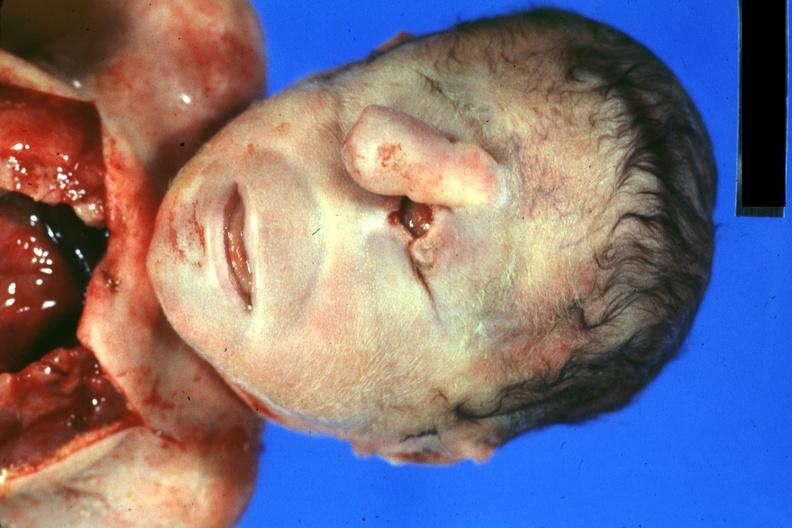what is present?
Answer the question using a single word or phrase. Face 